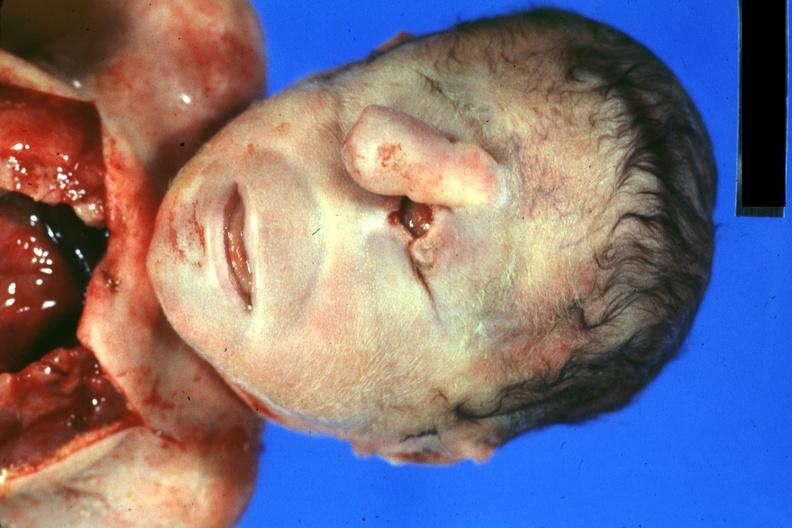what is present?
Answer the question using a single word or phrase. Face 